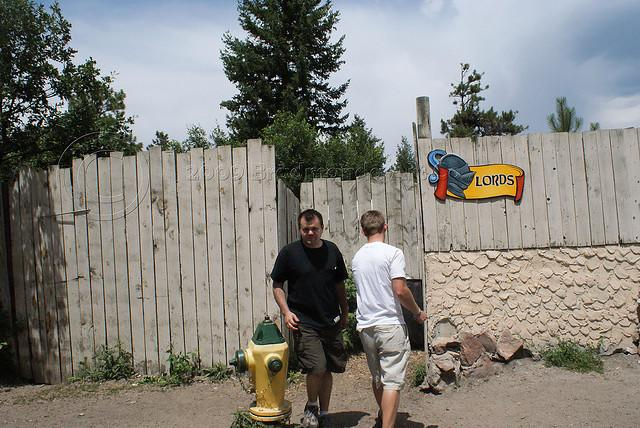What does the man in white need to use?

Choices:
A) grill
B) emergency exit
C) restroom
D) sword restroom 